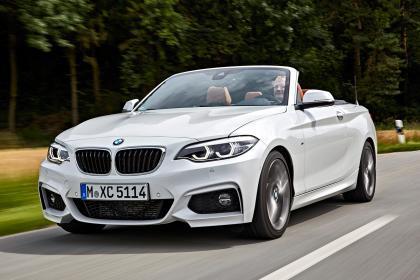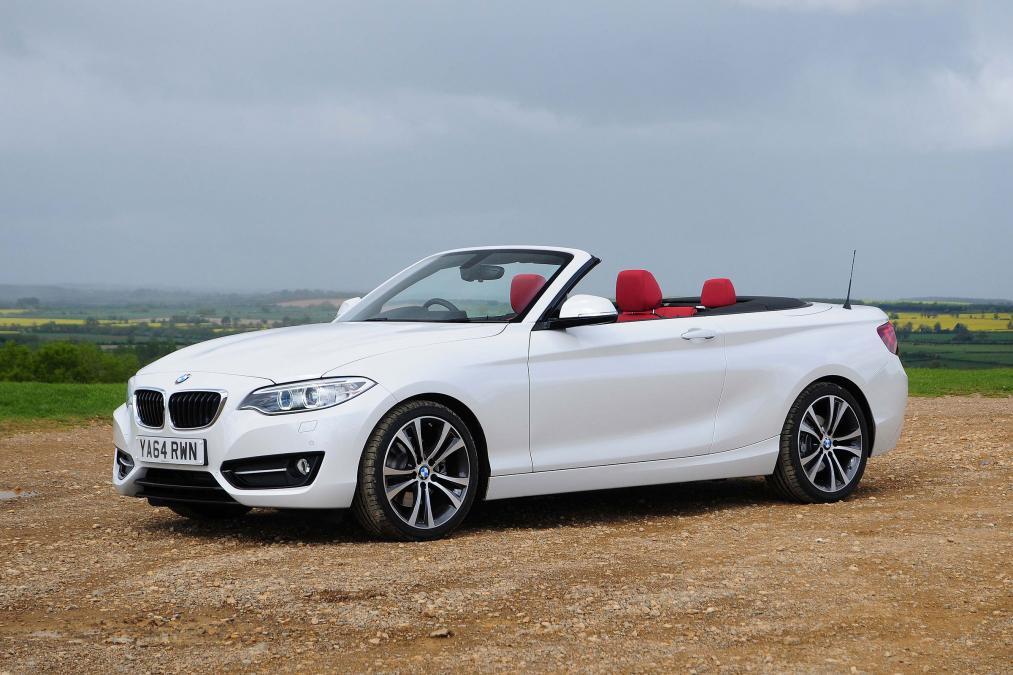The first image is the image on the left, the second image is the image on the right. For the images shown, is this caption "An image contains exactly one parked white convertible, which has red covered seats." true? Answer yes or no. Yes. The first image is the image on the left, the second image is the image on the right. Considering the images on both sides, is "One of the cars is black and the rest are white." valid? Answer yes or no. No. 